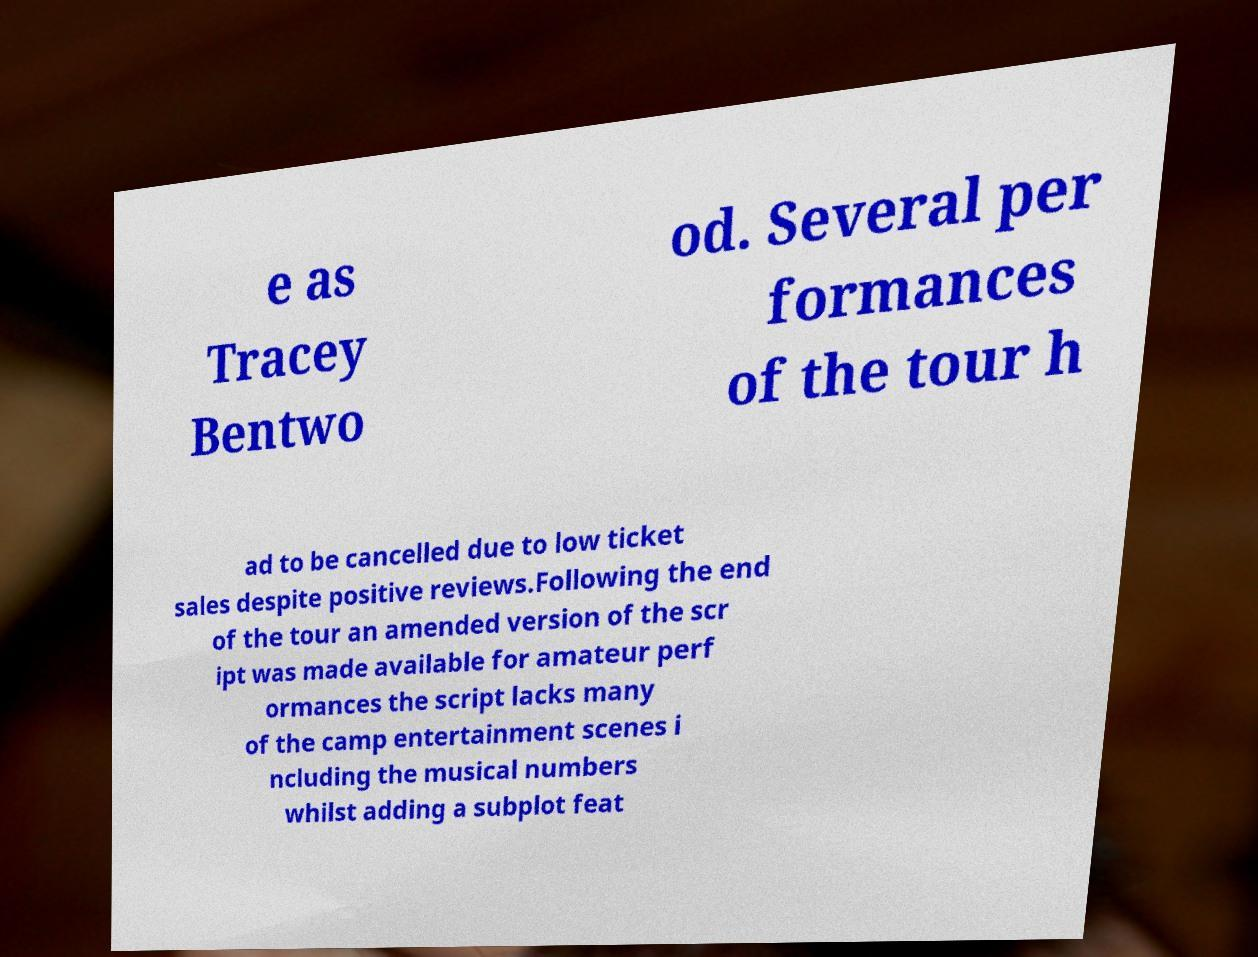What messages or text are displayed in this image? I need them in a readable, typed format. e as Tracey Bentwo od. Several per formances of the tour h ad to be cancelled due to low ticket sales despite positive reviews.Following the end of the tour an amended version of the scr ipt was made available for amateur perf ormances the script lacks many of the camp entertainment scenes i ncluding the musical numbers whilst adding a subplot feat 